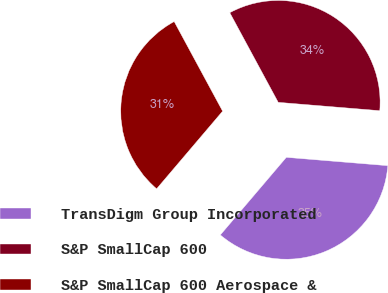<chart> <loc_0><loc_0><loc_500><loc_500><pie_chart><fcel>TransDigm Group Incorporated<fcel>S&P SmallCap 600<fcel>S&P SmallCap 600 Aerospace &<nl><fcel>34.91%<fcel>34.19%<fcel>30.9%<nl></chart> 